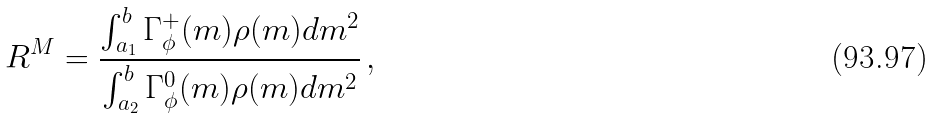<formula> <loc_0><loc_0><loc_500><loc_500>R ^ { M } = \frac { \int _ { a _ { 1 } } ^ { b } \Gamma ^ { + } _ { \phi } ( m ) \rho ( m ) d m ^ { 2 } } { \int _ { a _ { 2 } } ^ { b } \Gamma ^ { 0 } _ { \phi } ( m ) \rho ( m ) d m ^ { 2 } } \, ,</formula> 